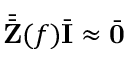Convert formula to latex. <formula><loc_0><loc_0><loc_500><loc_500>\bar { \bar { Z } } ( f ) \bar { I } \approx \bar { 0 }</formula> 